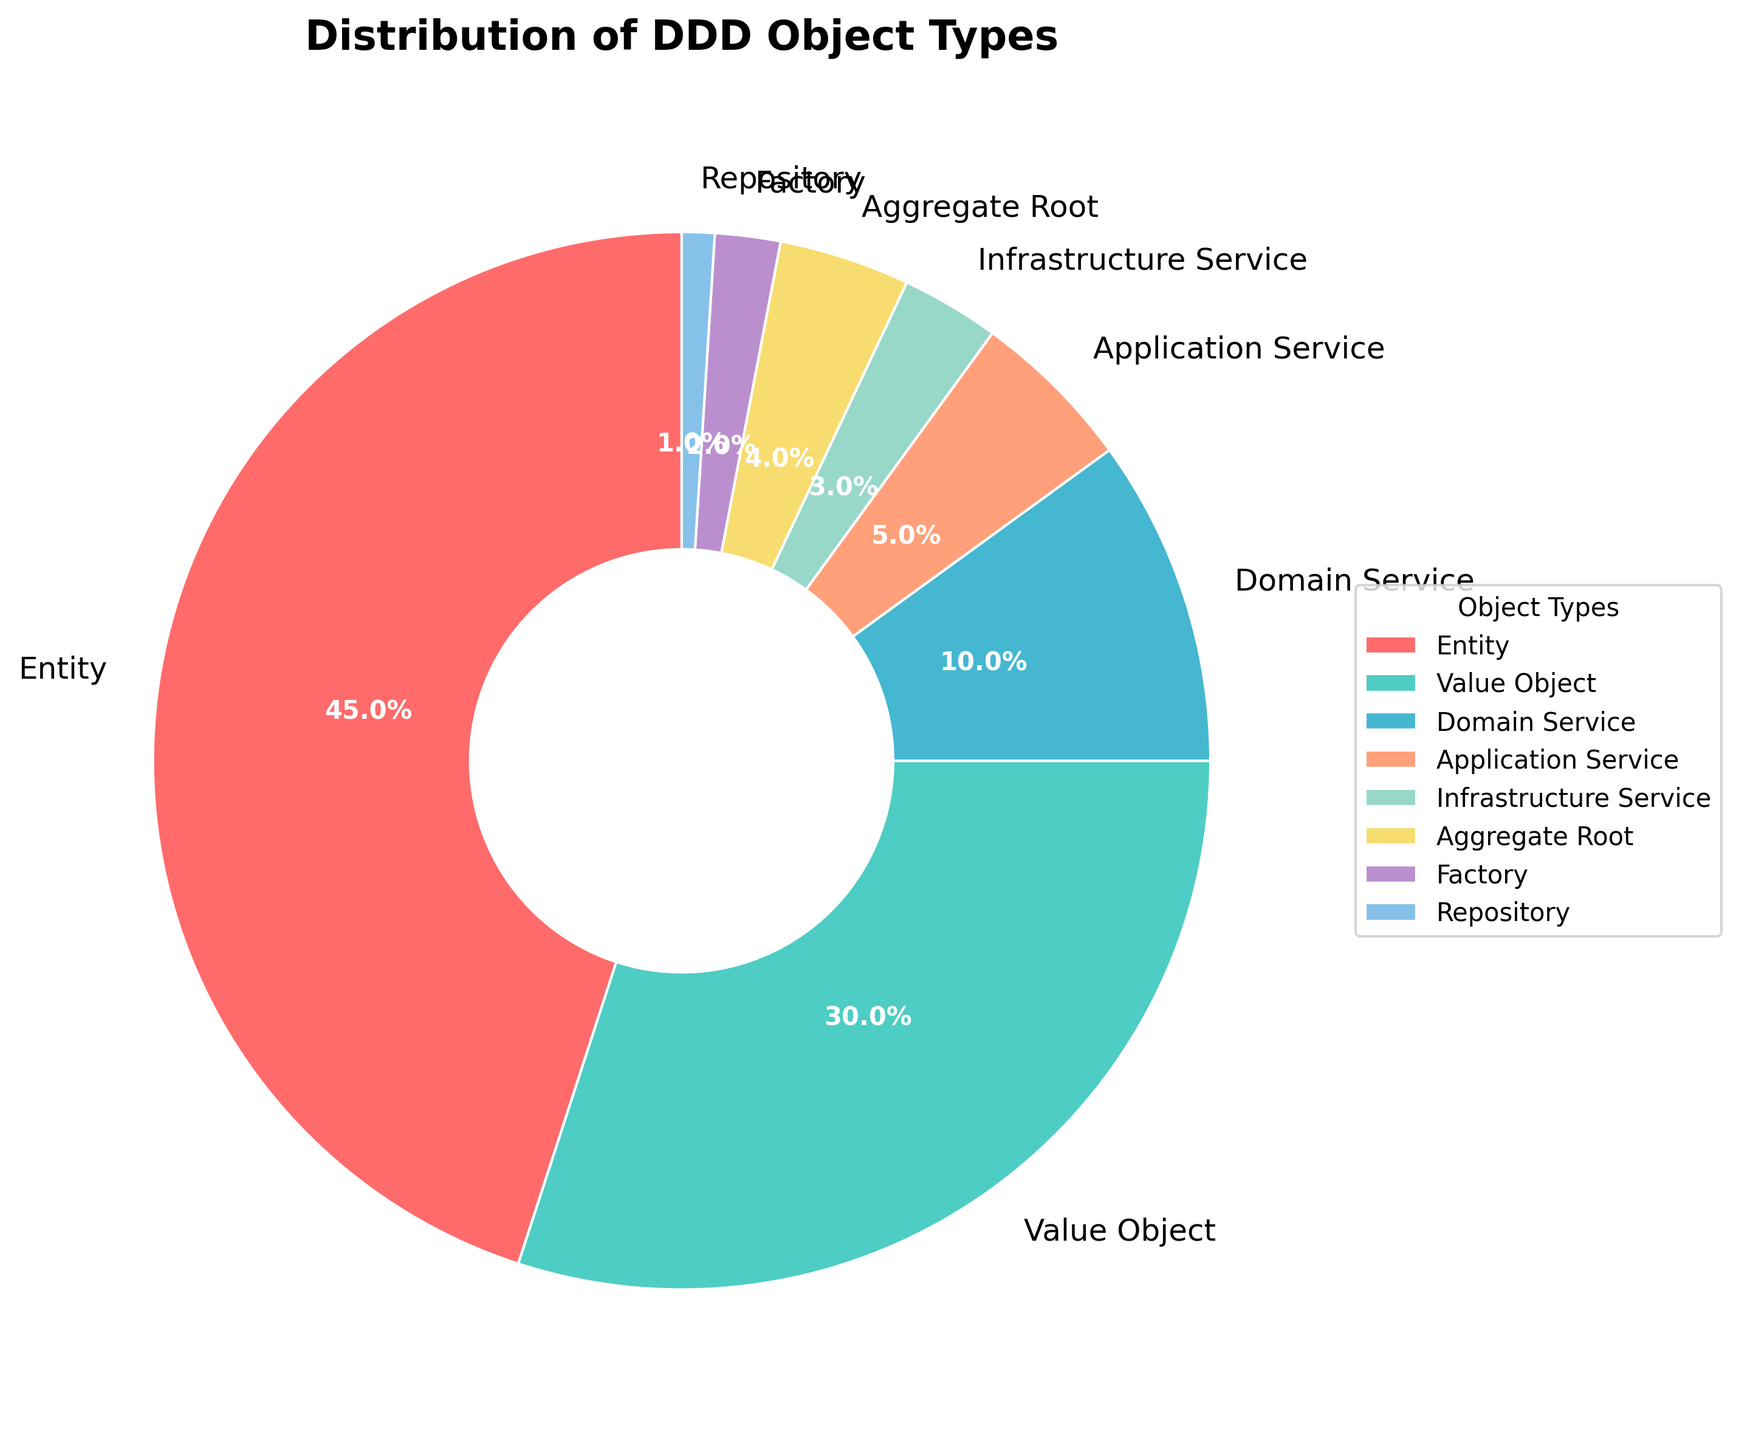Which type of object has the largest percentage? The object with the largest percentage will have the biggest wedge in the pie chart. Here, "Entity" has the largest section in the chart.
Answer: Entity How much larger is the percentage of Entities compared to Value Objects? The percentage of Entities is 45%, and the percentage of Value Objects is 30%. The difference is calculated as 45% - 30% = 15%.
Answer: 15% Which object type has a higher percentage, Domain Service or Application Service? The chart shows that Domain Service has a percentage of 10%, while Application Service has 5%. Since 10% is greater than 5%, Domain Service has a higher percentage.
Answer: Domain Service What is the combined percentage of Infrastructure Service and Repository? The percentages for Infrastructure Service and Repository are 3% and 1%, respectively. Adding them together gives 3% + 1% = 4%.
Answer: 4% Which of the object types have less than 5% representation in the chart? The segments less than 5% are identified as Application Service (5%), Infrastructure Service (3%), Aggregate Root (4%), Factory (2%), and Repository (1%). Removing Application Service which is exactly 5%, leaves Infrastructure Service, Aggregate Root, Factory, and Repository.
Answer: Infrastructure Service, Aggregate Root, Factory, Repository What percentage of the object types in total does not exceed 10% on their own? Summing the percentages less than or equal to 10%: Domain Service (10%), Application Service (5%), Infrastructure Service (3%), Aggregate Root (4%), Factory (2%), and Repository (1%). Adding these gives 10% + 5% + 3% + 4% + 2% + 1% = 25%.
Answer: 25% Compare the segments colored in shades of blue, which has a higher percentage among them? Two identified blue shades are used: Value Object (30%) and Application Service (5%). Since 30% is larger than 5%, Value Object has the higher percentage.
Answer: Value Object If the percentages of Factory and Repository were combined, would their total be more than any single percentage of Entity, Value Object, or Domain Service? Combining Factory (2%) and Repository (1%) gives 2% + 1% = 3%. Comparing this with Entity (45%), Value Object (30%), and Domain Service (10%), 3% is less in each case.
Answer: No 